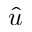<formula> <loc_0><loc_0><loc_500><loc_500>\hat { u }</formula> 